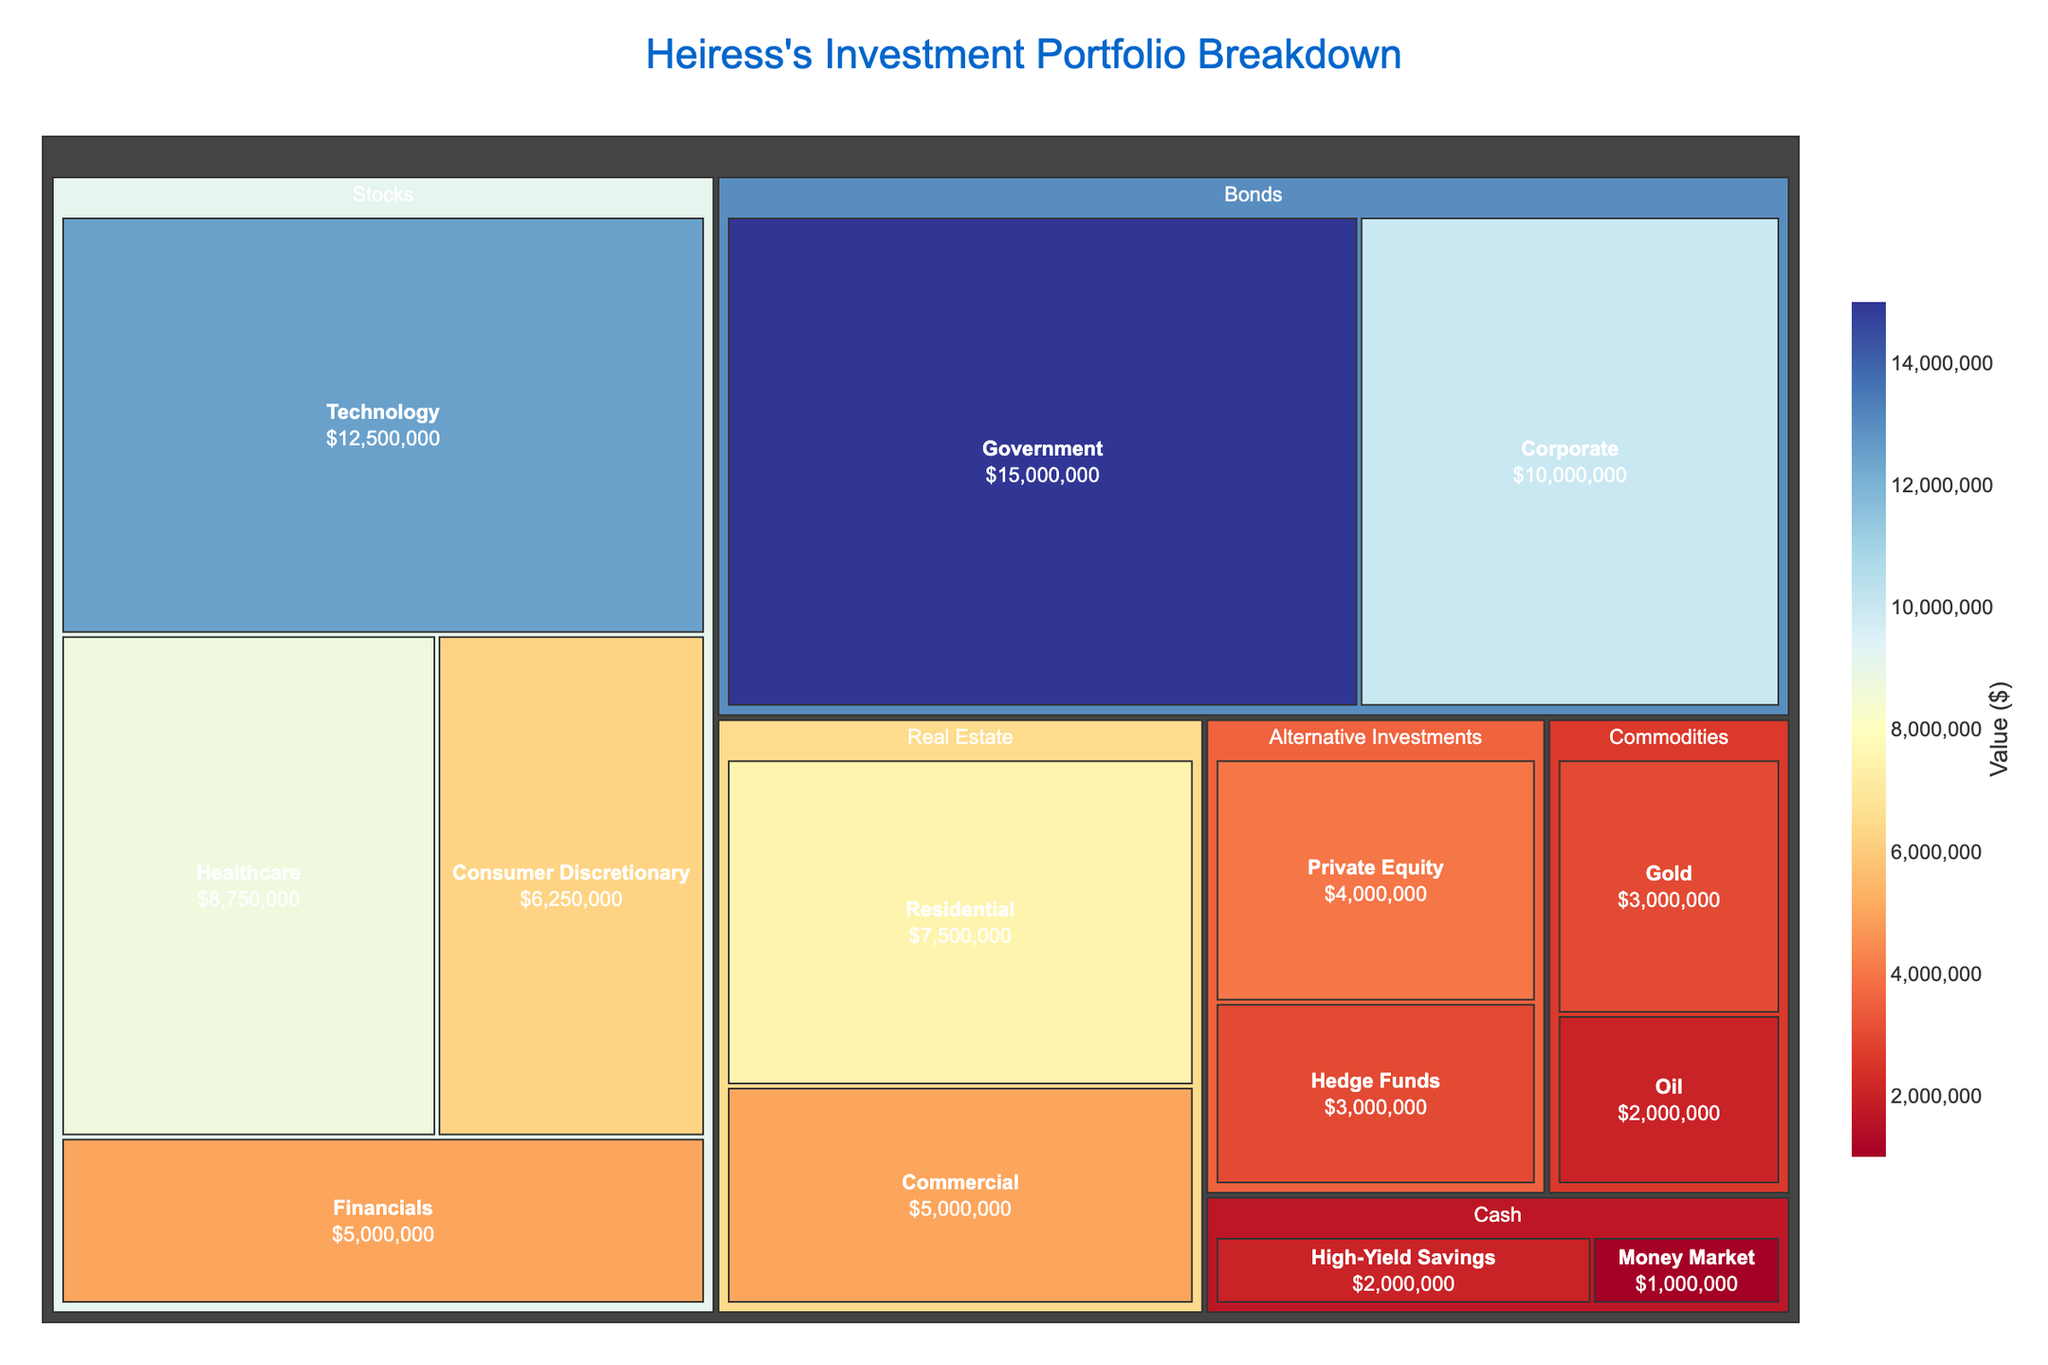What is the title of the Treemap? The title is typically located at the top center of the Treemap. Just read the text displayed there.
Answer: "Heiress's Investment Portfolio Breakdown" Which Asset Class has the highest total value? Sum the values of all sectors within each Asset Class and identify the class with the highest sum. Stocks: $32,500,000, Bonds: $25,000,000, Real Estate: $12,500,000, Commodities: $5,000,000, Alternative Investments: $7,000,000, Cash: $3,000,000
Answer: Stocks How much more is invested in Government Bonds compared to Corporate Bonds? Subtract the value of Corporate Bonds from Government Bonds. Government Bonds: $15,000,000, Corporate Bonds: $10,000,000. $15,000,000 - $10,000,000 = $5,000,000
Answer: $5,000,000 What is the color range used in the Treemap? Examine the color scale bar to determine the range. The color bar usually indicates the minimum to the maximum value and is colored accordingly.
Answer: Red to Blue Which sectors fall under the Asset Class "Real Estate"? Look for the hierarchy in the Treemap under "Real Estate" to find the listed sectors.
Answer: Residential, Commercial What is the total value of the Alternative Investments category? Sum the values for all sectors within Alternative Investments. Private Equity: $4,000,000, Hedge Funds: $3,000,000. $4,000,000 + $3,000,000 = $7,000,000
Answer: $7,000,000 Which sector within the Stocks Asset Class has the second highest value? Compare the values of sectors within Stocks and identify the second highest value. Technology: $12,500,000, Healthcare: $8,750,000, Consumer Discretionary: $6,250,000, Financials: $5,000,000
Answer: Healthcare What is the smallest total value among the Cash sectors? Compare the values within Cash to find the smallest one. High-Yield Savings: $2,000,000, Money Market: $1,000,000
Answer: Money Market How does the value of Real Estate compare with the value of Commodities? Compare the total values of Real Estate and Commodities. Real Estate: $12,500,000, Commodities: $5,000,000
Answer: Real Estate has a higher value What is the value of the Technology sector? Locate the Technology sector in the Treemap and read its value.
Answer: $12,500,000 